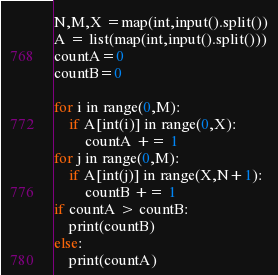Convert code to text. <code><loc_0><loc_0><loc_500><loc_500><_Python_>N,M,X =map(int,input().split())
A = list(map(int,input().split()))
countA=0
countB=0

for i in range(0,M):
    if A[int(i)] in range(0,X):
        countA += 1
for j in range(0,M):
    if A[int(j)] in range(X,N+1):
        countB += 1
if countA > countB:
    print(countB)
else:
    print(countA)
</code> 